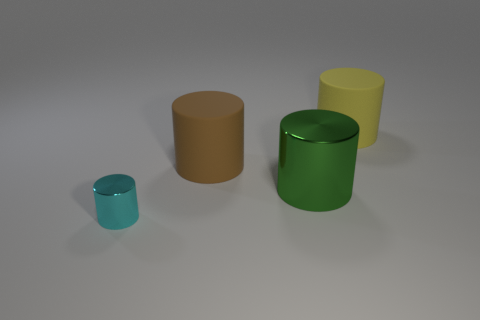What number of other objects are the same shape as the large green object?
Offer a terse response. 3. There is a green cylinder; does it have the same size as the rubber thing that is to the left of the yellow rubber thing?
Your answer should be compact. Yes. How many objects are either rubber objects on the left side of the green metallic object or large objects?
Your response must be concise. 3. There is a large rubber object that is right of the brown rubber object; what shape is it?
Offer a very short reply. Cylinder. Are there an equal number of small shiny things that are behind the big green shiny cylinder and yellow rubber cylinders that are on the left side of the brown thing?
Give a very brief answer. Yes. What color is the object that is to the left of the green shiny object and in front of the brown thing?
Provide a succinct answer. Cyan. The cylinder behind the large matte thing that is in front of the yellow thing is made of what material?
Keep it short and to the point. Rubber. Is the green metallic object the same size as the brown matte cylinder?
Offer a very short reply. Yes. What number of big objects are brown cylinders or green shiny cylinders?
Provide a short and direct response. 2. How many large green metal cylinders are to the left of the small cyan metal cylinder?
Your response must be concise. 0. 